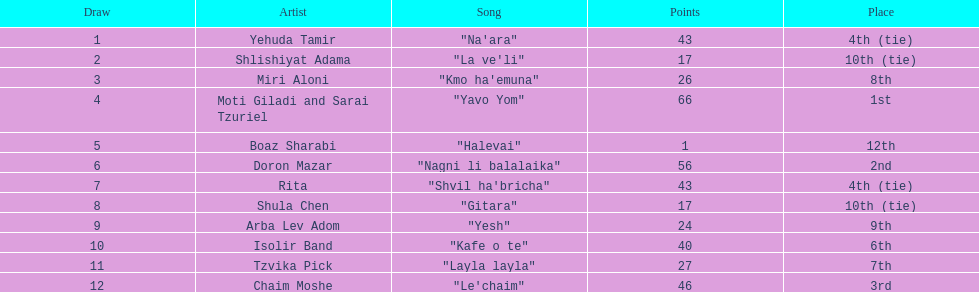In the table, what tune appears right preceding "layla layla"? "Kafe o te". 